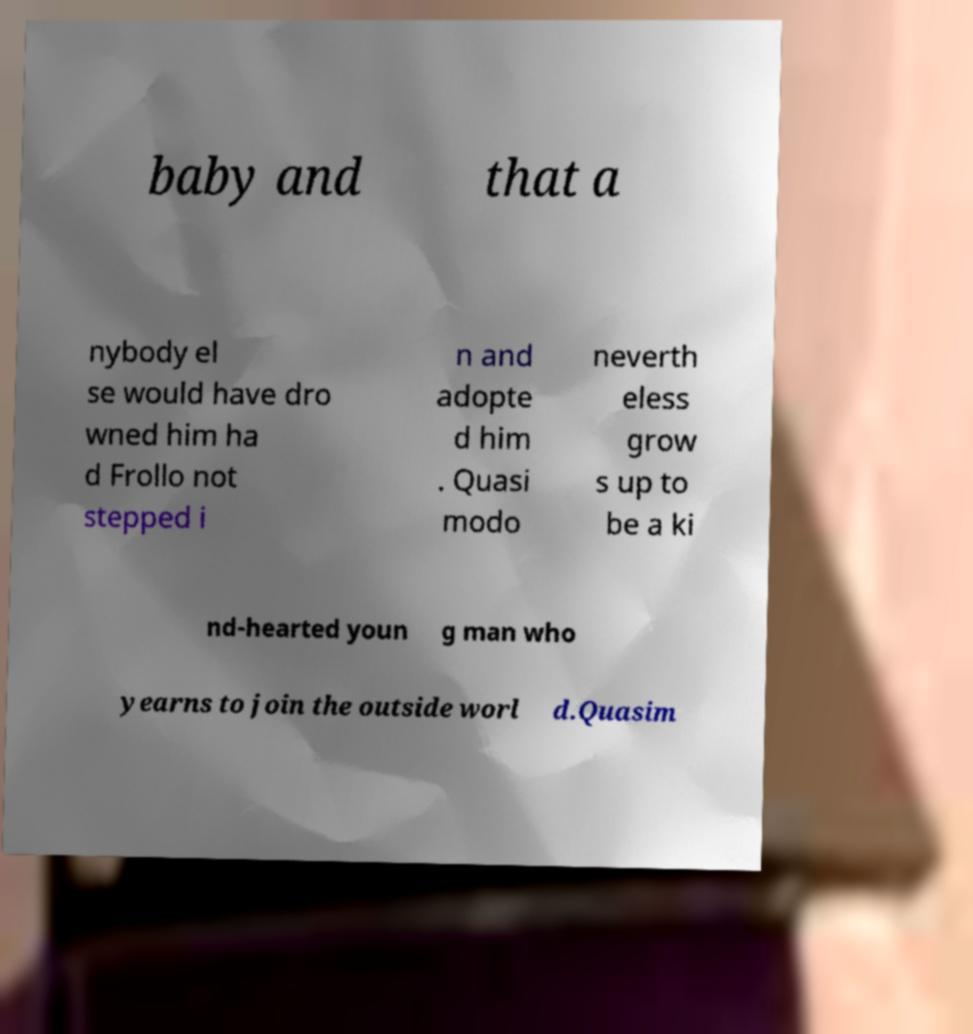Can you accurately transcribe the text from the provided image for me? baby and that a nybody el se would have dro wned him ha d Frollo not stepped i n and adopte d him . Quasi modo neverth eless grow s up to be a ki nd-hearted youn g man who yearns to join the outside worl d.Quasim 